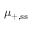Convert formula to latex. <formula><loc_0><loc_0><loc_500><loc_500>\mu _ { + , { s s } }</formula> 